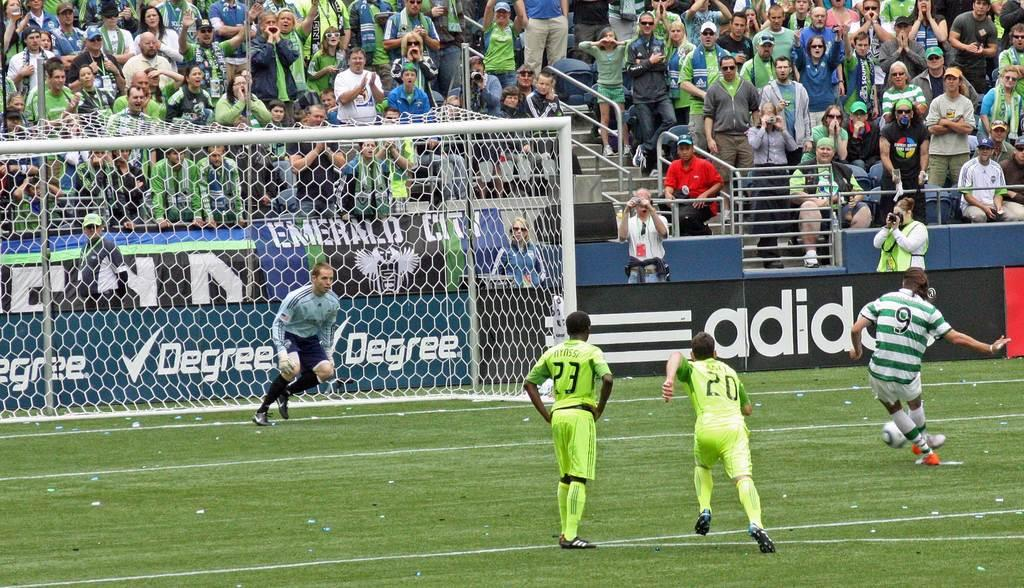What sport are the players engaged in? The players are playing football. Who is watching the players? There are audience members in front of the players. What is the condition of the ground where the game is taking place? The ground is covered in greenery. How many horses are present in the image? There are no horses present in the image. What type of expansion is taking place in the image? There is no expansion taking place in the image; it is a scene of a football game. 